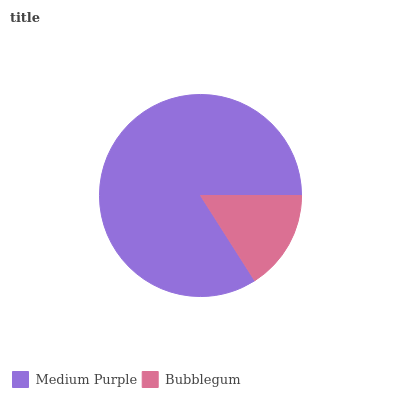Is Bubblegum the minimum?
Answer yes or no. Yes. Is Medium Purple the maximum?
Answer yes or no. Yes. Is Bubblegum the maximum?
Answer yes or no. No. Is Medium Purple greater than Bubblegum?
Answer yes or no. Yes. Is Bubblegum less than Medium Purple?
Answer yes or no. Yes. Is Bubblegum greater than Medium Purple?
Answer yes or no. No. Is Medium Purple less than Bubblegum?
Answer yes or no. No. Is Medium Purple the high median?
Answer yes or no. Yes. Is Bubblegum the low median?
Answer yes or no. Yes. Is Bubblegum the high median?
Answer yes or no. No. Is Medium Purple the low median?
Answer yes or no. No. 